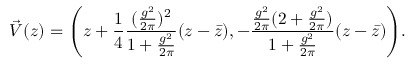<formula> <loc_0><loc_0><loc_500><loc_500>\vec { V } ( z ) = \left ( z + { \frac { 1 } { 4 } } { \frac { ( { \frac { g ^ { 2 } } { 2 \pi } } ) ^ { 2 } } { 1 + { \frac { g ^ { 2 } } { 2 \pi } } } } ( z - \bar { z } ) , - { \frac { { \frac { g ^ { 2 } } { 2 \pi } } ( 2 + { \frac { g ^ { 2 } } { 2 \pi } } ) } { 1 + { \frac { g ^ { 2 } } { 2 \pi } } } } ( z - \bar { z } ) \right ) .</formula> 